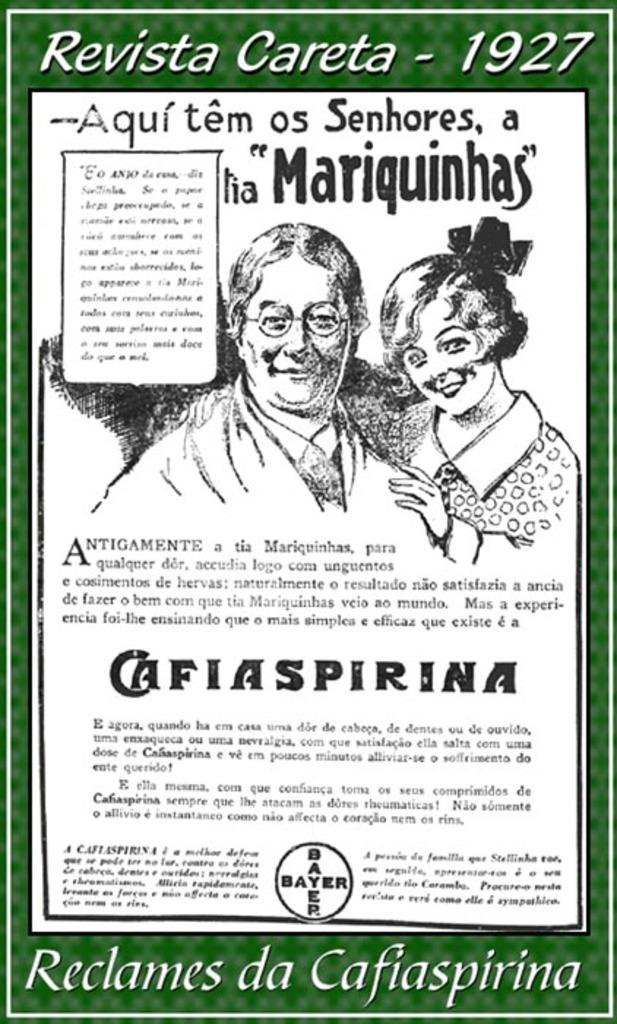What is the main subject of the image? The main subject of the image is an article with information. What are the people in the image doing to the article? The people in the image are drawing on the article. What color are the borders of the article? The article has green borders. Can you tell me how many mittens are being worn by the monkey in the image? There is no monkey or mitten present in the image; it features an article with people drawing on it. 